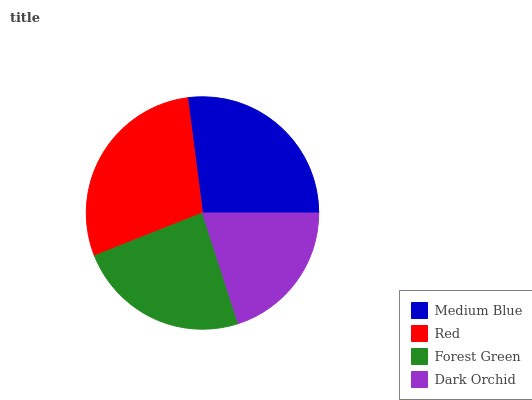Is Dark Orchid the minimum?
Answer yes or no. Yes. Is Red the maximum?
Answer yes or no. Yes. Is Forest Green the minimum?
Answer yes or no. No. Is Forest Green the maximum?
Answer yes or no. No. Is Red greater than Forest Green?
Answer yes or no. Yes. Is Forest Green less than Red?
Answer yes or no. Yes. Is Forest Green greater than Red?
Answer yes or no. No. Is Red less than Forest Green?
Answer yes or no. No. Is Medium Blue the high median?
Answer yes or no. Yes. Is Forest Green the low median?
Answer yes or no. Yes. Is Forest Green the high median?
Answer yes or no. No. Is Medium Blue the low median?
Answer yes or no. No. 